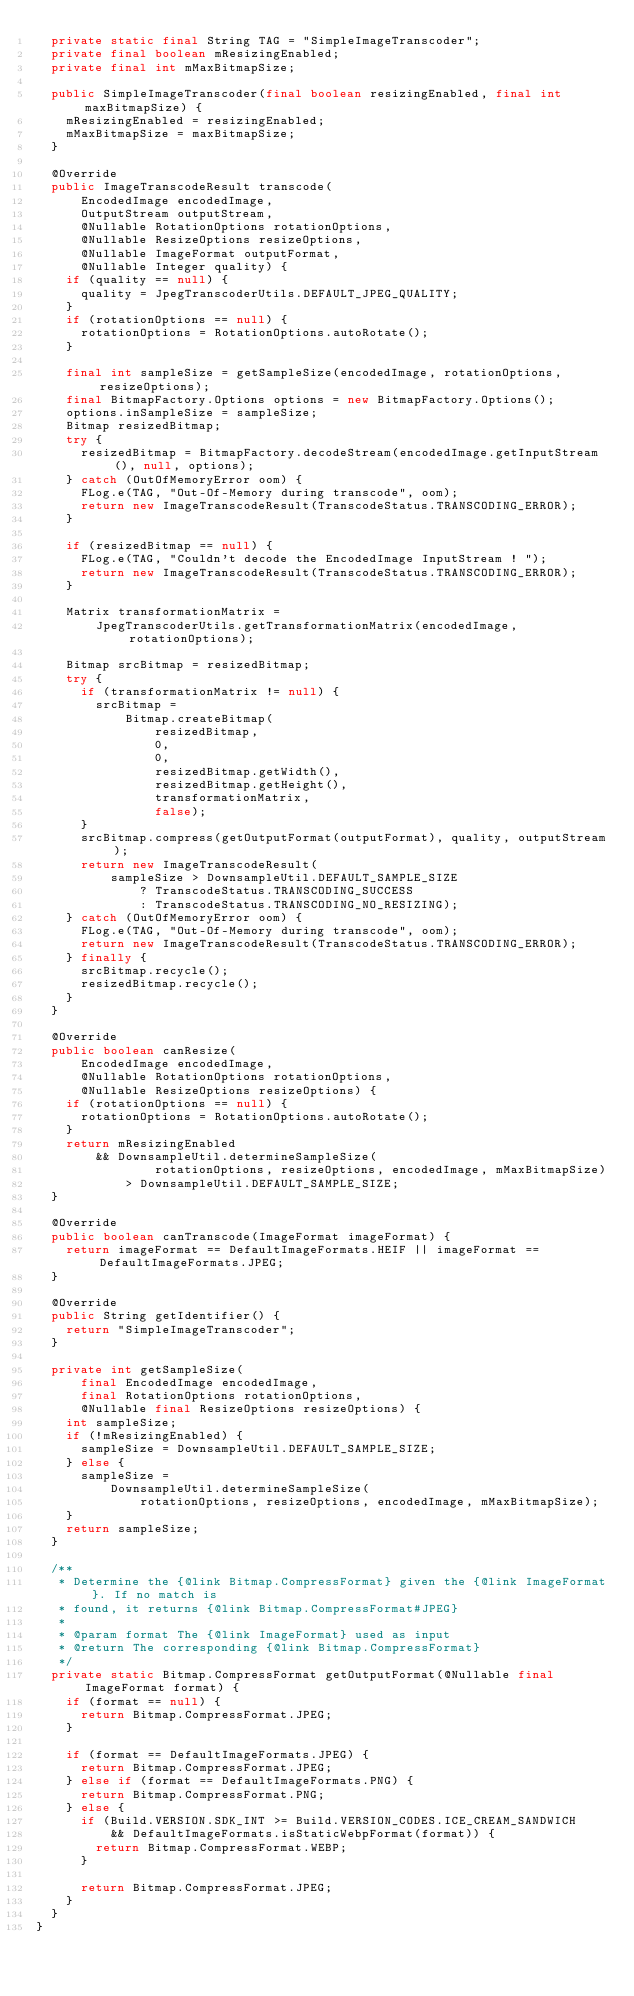Convert code to text. <code><loc_0><loc_0><loc_500><loc_500><_Java_>  private static final String TAG = "SimpleImageTranscoder";
  private final boolean mResizingEnabled;
  private final int mMaxBitmapSize;

  public SimpleImageTranscoder(final boolean resizingEnabled, final int maxBitmapSize) {
    mResizingEnabled = resizingEnabled;
    mMaxBitmapSize = maxBitmapSize;
  }

  @Override
  public ImageTranscodeResult transcode(
      EncodedImage encodedImage,
      OutputStream outputStream,
      @Nullable RotationOptions rotationOptions,
      @Nullable ResizeOptions resizeOptions,
      @Nullable ImageFormat outputFormat,
      @Nullable Integer quality) {
    if (quality == null) {
      quality = JpegTranscoderUtils.DEFAULT_JPEG_QUALITY;
    }
    if (rotationOptions == null) {
      rotationOptions = RotationOptions.autoRotate();
    }

    final int sampleSize = getSampleSize(encodedImage, rotationOptions, resizeOptions);
    final BitmapFactory.Options options = new BitmapFactory.Options();
    options.inSampleSize = sampleSize;
    Bitmap resizedBitmap;
    try {
      resizedBitmap = BitmapFactory.decodeStream(encodedImage.getInputStream(), null, options);
    } catch (OutOfMemoryError oom) {
      FLog.e(TAG, "Out-Of-Memory during transcode", oom);
      return new ImageTranscodeResult(TranscodeStatus.TRANSCODING_ERROR);
    }

    if (resizedBitmap == null) {
      FLog.e(TAG, "Couldn't decode the EncodedImage InputStream ! ");
      return new ImageTranscodeResult(TranscodeStatus.TRANSCODING_ERROR);
    }

    Matrix transformationMatrix =
        JpegTranscoderUtils.getTransformationMatrix(encodedImage, rotationOptions);

    Bitmap srcBitmap = resizedBitmap;
    try {
      if (transformationMatrix != null) {
        srcBitmap =
            Bitmap.createBitmap(
                resizedBitmap,
                0,
                0,
                resizedBitmap.getWidth(),
                resizedBitmap.getHeight(),
                transformationMatrix,
                false);
      }
      srcBitmap.compress(getOutputFormat(outputFormat), quality, outputStream);
      return new ImageTranscodeResult(
          sampleSize > DownsampleUtil.DEFAULT_SAMPLE_SIZE
              ? TranscodeStatus.TRANSCODING_SUCCESS
              : TranscodeStatus.TRANSCODING_NO_RESIZING);
    } catch (OutOfMemoryError oom) {
      FLog.e(TAG, "Out-Of-Memory during transcode", oom);
      return new ImageTranscodeResult(TranscodeStatus.TRANSCODING_ERROR);
    } finally {
      srcBitmap.recycle();
      resizedBitmap.recycle();
    }
  }

  @Override
  public boolean canResize(
      EncodedImage encodedImage,
      @Nullable RotationOptions rotationOptions,
      @Nullable ResizeOptions resizeOptions) {
    if (rotationOptions == null) {
      rotationOptions = RotationOptions.autoRotate();
    }
    return mResizingEnabled
        && DownsampleUtil.determineSampleSize(
                rotationOptions, resizeOptions, encodedImage, mMaxBitmapSize)
            > DownsampleUtil.DEFAULT_SAMPLE_SIZE;
  }

  @Override
  public boolean canTranscode(ImageFormat imageFormat) {
    return imageFormat == DefaultImageFormats.HEIF || imageFormat == DefaultImageFormats.JPEG;
  }

  @Override
  public String getIdentifier() {
    return "SimpleImageTranscoder";
  }

  private int getSampleSize(
      final EncodedImage encodedImage,
      final RotationOptions rotationOptions,
      @Nullable final ResizeOptions resizeOptions) {
    int sampleSize;
    if (!mResizingEnabled) {
      sampleSize = DownsampleUtil.DEFAULT_SAMPLE_SIZE;
    } else {
      sampleSize =
          DownsampleUtil.determineSampleSize(
              rotationOptions, resizeOptions, encodedImage, mMaxBitmapSize);
    }
    return sampleSize;
  }

  /**
   * Determine the {@link Bitmap.CompressFormat} given the {@link ImageFormat}. If no match is
   * found, it returns {@link Bitmap.CompressFormat#JPEG}
   *
   * @param format The {@link ImageFormat} used as input
   * @return The corresponding {@link Bitmap.CompressFormat}
   */
  private static Bitmap.CompressFormat getOutputFormat(@Nullable final ImageFormat format) {
    if (format == null) {
      return Bitmap.CompressFormat.JPEG;
    }

    if (format == DefaultImageFormats.JPEG) {
      return Bitmap.CompressFormat.JPEG;
    } else if (format == DefaultImageFormats.PNG) {
      return Bitmap.CompressFormat.PNG;
    } else {
      if (Build.VERSION.SDK_INT >= Build.VERSION_CODES.ICE_CREAM_SANDWICH
          && DefaultImageFormats.isStaticWebpFormat(format)) {
        return Bitmap.CompressFormat.WEBP;
      }

      return Bitmap.CompressFormat.JPEG;
    }
  }
}
</code> 